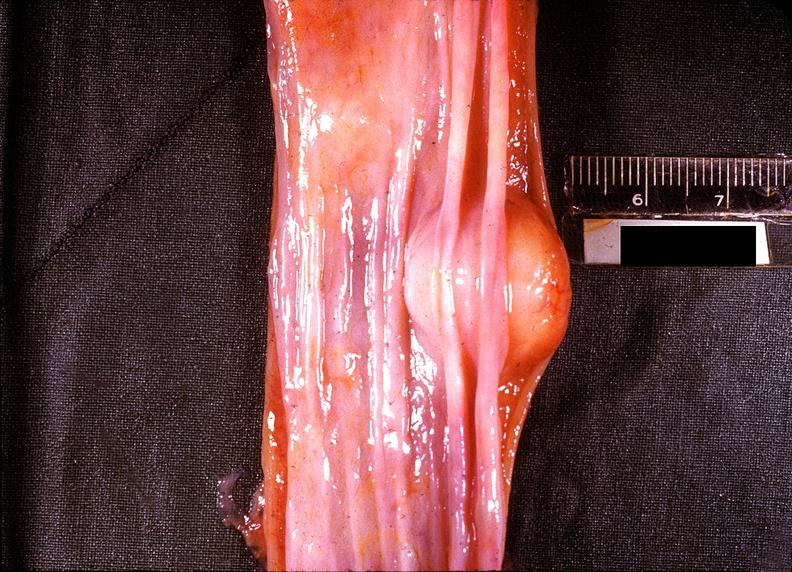where does this belong to?
Answer the question using a single word or phrase. Gastrointestinal system 